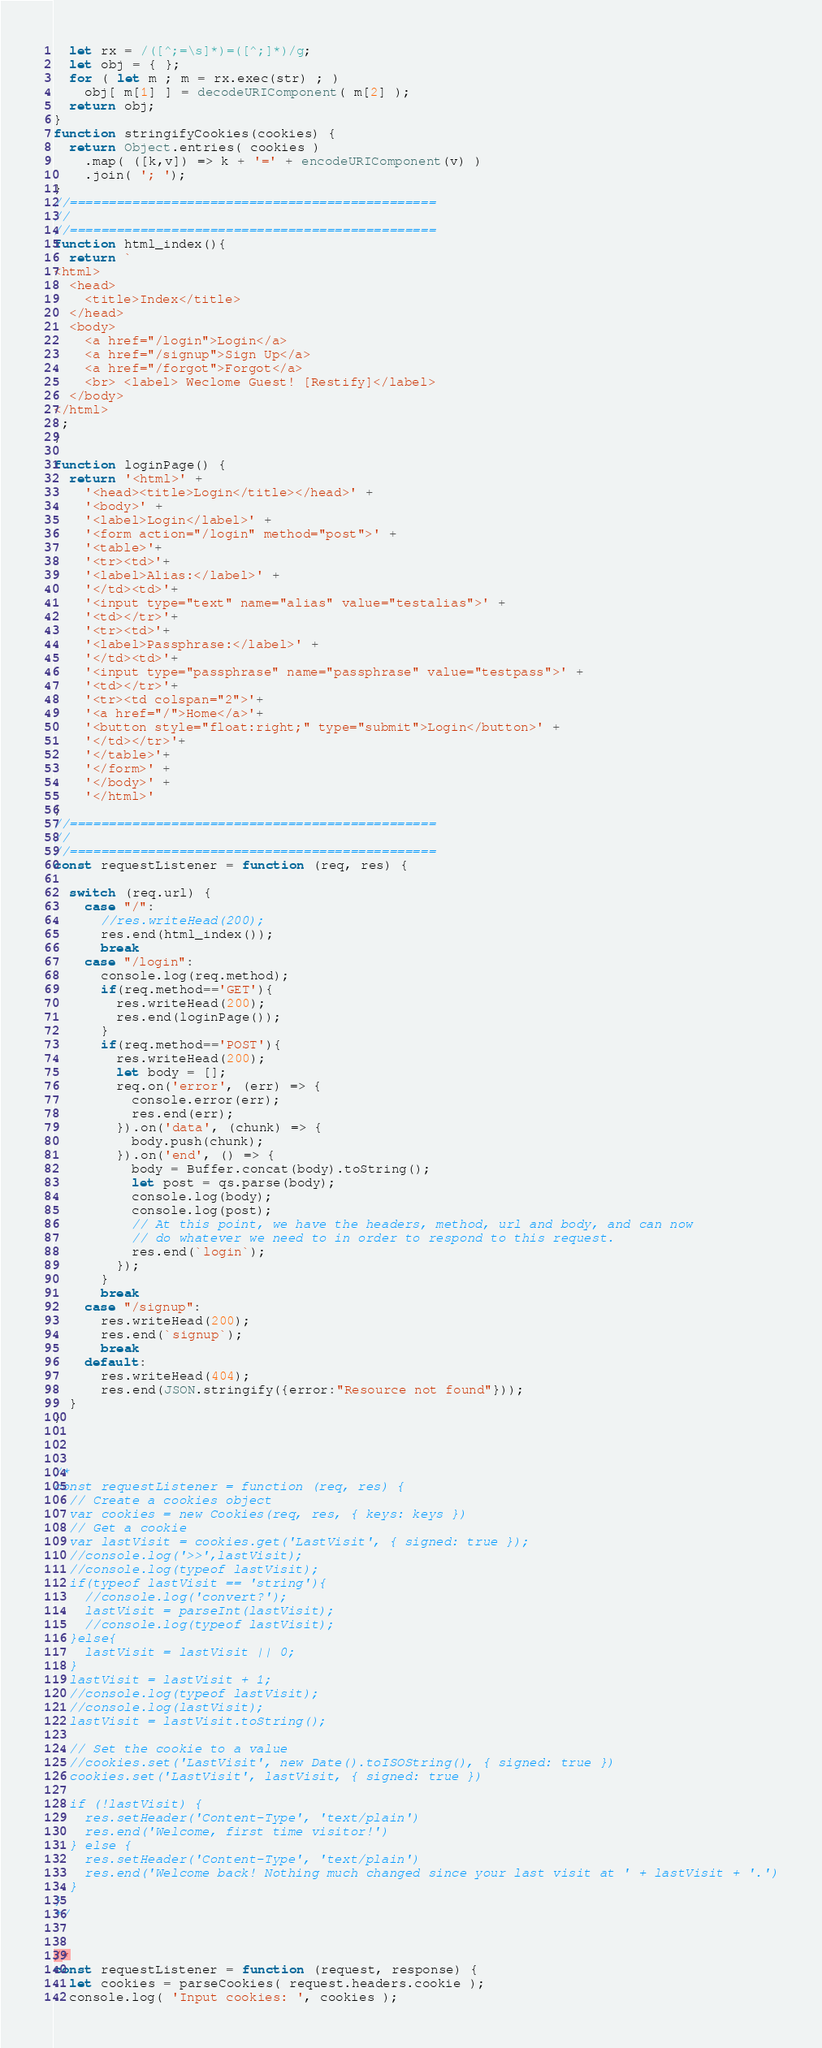Convert code to text. <code><loc_0><loc_0><loc_500><loc_500><_JavaScript_>  let rx = /([^;=\s]*)=([^;]*)/g;
  let obj = { };
  for ( let m ; m = rx.exec(str) ; )
    obj[ m[1] ] = decodeURIComponent( m[2] );
  return obj;
}
function stringifyCookies(cookies) {
  return Object.entries( cookies )
    .map( ([k,v]) => k + '=' + encodeURIComponent(v) )
    .join( '; ');
}
//===============================================
//
//===============================================
function html_index(){
  return `
<html>
  <head>
    <title>Index</title>
  </head>
  <body>
    <a href="/login">Login</a>
    <a href="/signup">Sign Up</a>
    <a href="/forgot">Forgot</a>
    <br> <label> Weclome Guest! [Restify]</label>
  </body>
</html>
`;
}

function loginPage() {
  return '<html>' +
    '<head><title>Login</title></head>' +
    '<body>' +
    '<label>Login</label>' +
    '<form action="/login" method="post">' +
    '<table>'+
    '<tr><td>'+
    '<label>Alias:</label>' +
    '</td><td>'+
    '<input type="text" name="alias" value="testalias">' +
    '<td></tr>'+
    '<tr><td>'+
    '<label>Passphrase:</label>' +
    '</td><td>'+
    '<input type="passphrase" name="passphrase" value="testpass">' +
    '<td></tr>'+
    '<tr><td colspan="2">'+
    '<a href="/">Home</a>'+
    '<button style="float:right;" type="submit">Login</button>' +
    '</td></tr>'+
    '</table>'+
    '</form>' +
    '</body>' +
    '</html>'
}
//===============================================
//
//===============================================
const requestListener = function (req, res) {

  switch (req.url) {
    case "/":
      //res.writeHead(200);
      res.end(html_index());
      break
    case "/login":
      console.log(req.method);
      if(req.method=='GET'){
        res.writeHead(200);
        res.end(loginPage());
      }
      if(req.method=='POST'){
        res.writeHead(200);
        let body = [];
        req.on('error', (err) => {
          console.error(err);
          res.end(err);
        }).on('data', (chunk) => {
          body.push(chunk);
        }).on('end', () => {
          body = Buffer.concat(body).toString();
          let post = qs.parse(body);
          console.log(body);
          console.log(post);
          // At this point, we have the headers, method, url and body, and can now
          // do whatever we need to in order to respond to this request.
          res.end(`login`);
        });
      }
      break
    case "/signup":
      res.writeHead(200);
      res.end(`signup`);
      break
    default:
      res.writeHead(404);
      res.end(JSON.stringify({error:"Resource not found"}));
  }
}



/*
const requestListener = function (req, res) {
  // Create a cookies object
  var cookies = new Cookies(req, res, { keys: keys })
  // Get a cookie
  var lastVisit = cookies.get('LastVisit', { signed: true });
  //console.log('>>',lastVisit);
  //console.log(typeof lastVisit);
  if(typeof lastVisit == 'string'){
    //console.log('convert?');
    lastVisit = parseInt(lastVisit);
    //console.log(typeof lastVisit);
  }else{
    lastVisit = lastVisit || 0;
  }
  lastVisit = lastVisit + 1;
  //console.log(typeof lastVisit);
  //console.log(lastVisit);
  lastVisit = lastVisit.toString();

  // Set the cookie to a value
  //cookies.set('LastVisit', new Date().toISOString(), { signed: true })
  cookies.set('LastVisit', lastVisit, { signed: true })

  if (!lastVisit) {
    res.setHeader('Content-Type', 'text/plain')
    res.end('Welcome, first time visitor!')
  } else {
    res.setHeader('Content-Type', 'text/plain')
    res.end('Welcome back! Nothing much changed since your last visit at ' + lastVisit + '.')
  }
}
*/


/*
const requestListener = function (request, response) {
  let cookies = parseCookies( request.headers.cookie );
  console.log( 'Input cookies: ', cookies );</code> 